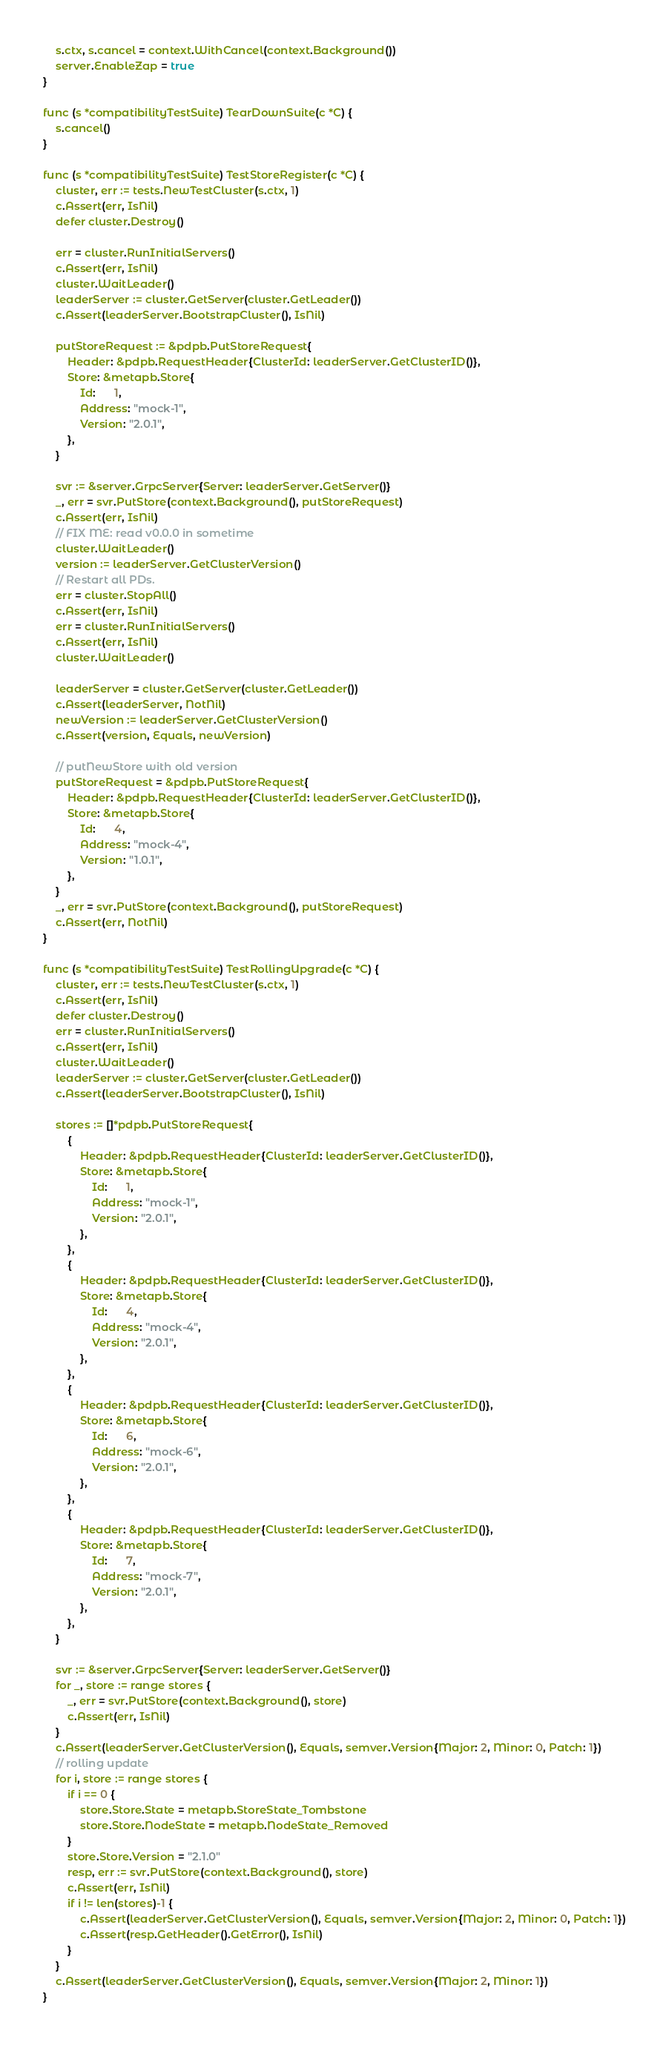Convert code to text. <code><loc_0><loc_0><loc_500><loc_500><_Go_>	s.ctx, s.cancel = context.WithCancel(context.Background())
	server.EnableZap = true
}

func (s *compatibilityTestSuite) TearDownSuite(c *C) {
	s.cancel()
}

func (s *compatibilityTestSuite) TestStoreRegister(c *C) {
	cluster, err := tests.NewTestCluster(s.ctx, 1)
	c.Assert(err, IsNil)
	defer cluster.Destroy()

	err = cluster.RunInitialServers()
	c.Assert(err, IsNil)
	cluster.WaitLeader()
	leaderServer := cluster.GetServer(cluster.GetLeader())
	c.Assert(leaderServer.BootstrapCluster(), IsNil)

	putStoreRequest := &pdpb.PutStoreRequest{
		Header: &pdpb.RequestHeader{ClusterId: leaderServer.GetClusterID()},
		Store: &metapb.Store{
			Id:      1,
			Address: "mock-1",
			Version: "2.0.1",
		},
	}

	svr := &server.GrpcServer{Server: leaderServer.GetServer()}
	_, err = svr.PutStore(context.Background(), putStoreRequest)
	c.Assert(err, IsNil)
	// FIX ME: read v0.0.0 in sometime
	cluster.WaitLeader()
	version := leaderServer.GetClusterVersion()
	// Restart all PDs.
	err = cluster.StopAll()
	c.Assert(err, IsNil)
	err = cluster.RunInitialServers()
	c.Assert(err, IsNil)
	cluster.WaitLeader()

	leaderServer = cluster.GetServer(cluster.GetLeader())
	c.Assert(leaderServer, NotNil)
	newVersion := leaderServer.GetClusterVersion()
	c.Assert(version, Equals, newVersion)

	// putNewStore with old version
	putStoreRequest = &pdpb.PutStoreRequest{
		Header: &pdpb.RequestHeader{ClusterId: leaderServer.GetClusterID()},
		Store: &metapb.Store{
			Id:      4,
			Address: "mock-4",
			Version: "1.0.1",
		},
	}
	_, err = svr.PutStore(context.Background(), putStoreRequest)
	c.Assert(err, NotNil)
}

func (s *compatibilityTestSuite) TestRollingUpgrade(c *C) {
	cluster, err := tests.NewTestCluster(s.ctx, 1)
	c.Assert(err, IsNil)
	defer cluster.Destroy()
	err = cluster.RunInitialServers()
	c.Assert(err, IsNil)
	cluster.WaitLeader()
	leaderServer := cluster.GetServer(cluster.GetLeader())
	c.Assert(leaderServer.BootstrapCluster(), IsNil)

	stores := []*pdpb.PutStoreRequest{
		{
			Header: &pdpb.RequestHeader{ClusterId: leaderServer.GetClusterID()},
			Store: &metapb.Store{
				Id:      1,
				Address: "mock-1",
				Version: "2.0.1",
			},
		},
		{
			Header: &pdpb.RequestHeader{ClusterId: leaderServer.GetClusterID()},
			Store: &metapb.Store{
				Id:      4,
				Address: "mock-4",
				Version: "2.0.1",
			},
		},
		{
			Header: &pdpb.RequestHeader{ClusterId: leaderServer.GetClusterID()},
			Store: &metapb.Store{
				Id:      6,
				Address: "mock-6",
				Version: "2.0.1",
			},
		},
		{
			Header: &pdpb.RequestHeader{ClusterId: leaderServer.GetClusterID()},
			Store: &metapb.Store{
				Id:      7,
				Address: "mock-7",
				Version: "2.0.1",
			},
		},
	}

	svr := &server.GrpcServer{Server: leaderServer.GetServer()}
	for _, store := range stores {
		_, err = svr.PutStore(context.Background(), store)
		c.Assert(err, IsNil)
	}
	c.Assert(leaderServer.GetClusterVersion(), Equals, semver.Version{Major: 2, Minor: 0, Patch: 1})
	// rolling update
	for i, store := range stores {
		if i == 0 {
			store.Store.State = metapb.StoreState_Tombstone
			store.Store.NodeState = metapb.NodeState_Removed
		}
		store.Store.Version = "2.1.0"
		resp, err := svr.PutStore(context.Background(), store)
		c.Assert(err, IsNil)
		if i != len(stores)-1 {
			c.Assert(leaderServer.GetClusterVersion(), Equals, semver.Version{Major: 2, Minor: 0, Patch: 1})
			c.Assert(resp.GetHeader().GetError(), IsNil)
		}
	}
	c.Assert(leaderServer.GetClusterVersion(), Equals, semver.Version{Major: 2, Minor: 1})
}
</code> 